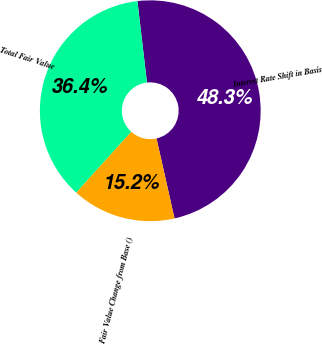<chart> <loc_0><loc_0><loc_500><loc_500><pie_chart><fcel>Interest Rate Shift in Basis<fcel>Total Fair Value<fcel>Fair Value Change from Base ()<nl><fcel>48.33%<fcel>36.44%<fcel>15.22%<nl></chart> 